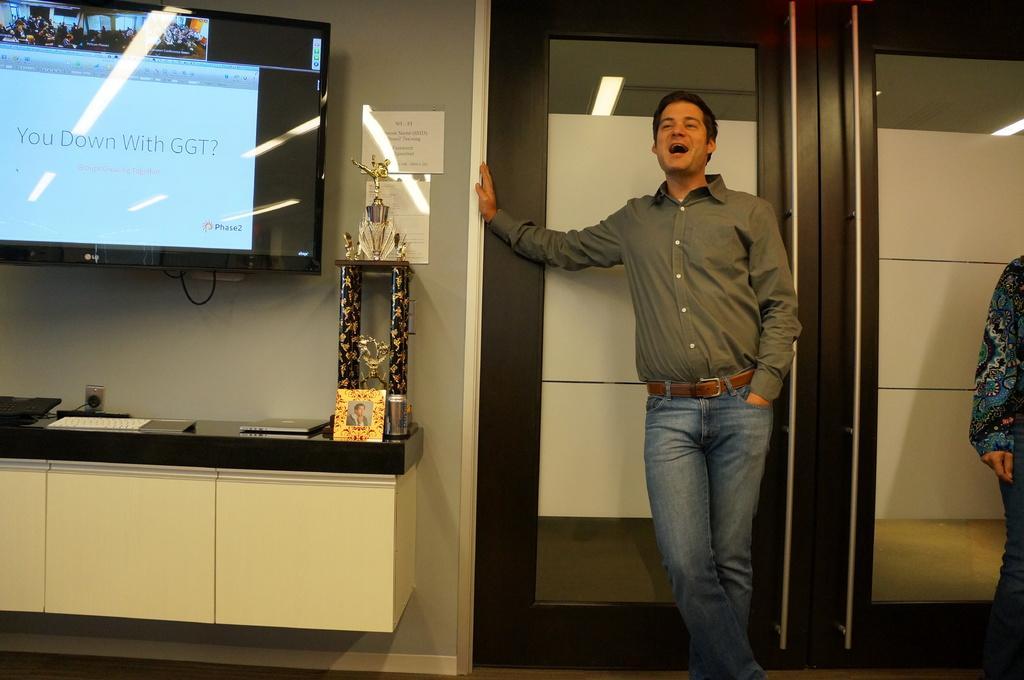Could you give a brief overview of what you see in this image? In this image there is a person standing in front of a door, on the left of a person there is another person standing, to the right of the person there is a wall mounted television, beside the television, there are posters on the wall, in front of the television there are some objects on the wooden platform. 